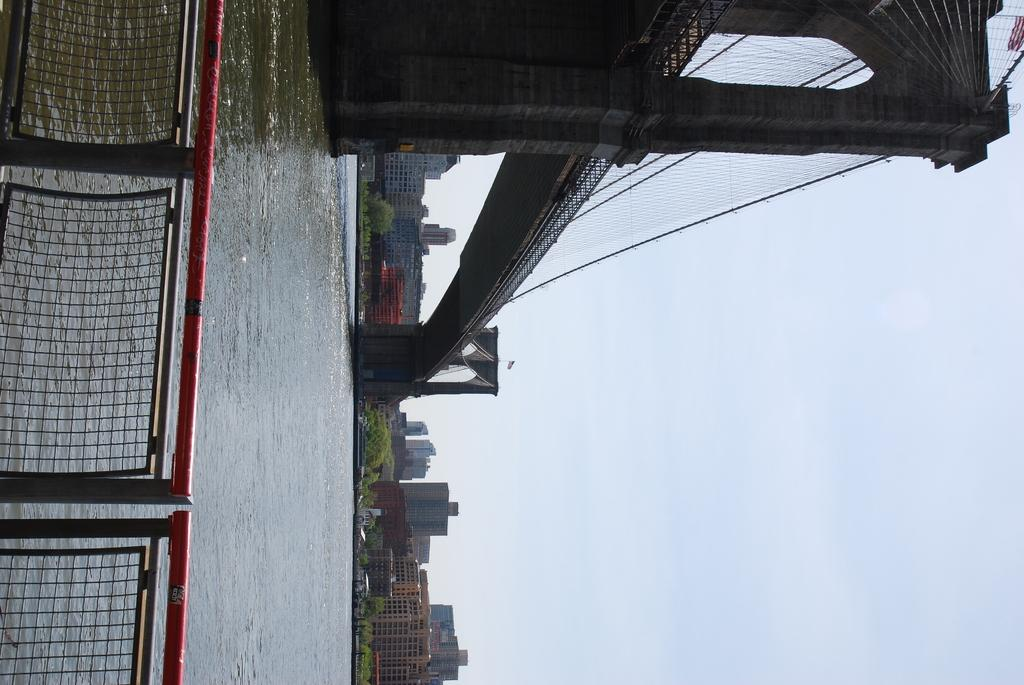What is the primary element present in the image? There is water in the image. What type of structure can be seen in the image? There is a bridge in the image. What can be used to provide support or safety in the image? There is railing in the image. What type of vegetation is present in the image? There are trees in the image. What type of man-made structures are visible in the image? There are buildings in the image. What part of the sky is visible in the image? The sky is visible on the right side of the image. What type of chin is visible on the bridge in the image? There is no chin visible in the image, as the bridge is an inanimate object and does not have a chin. 